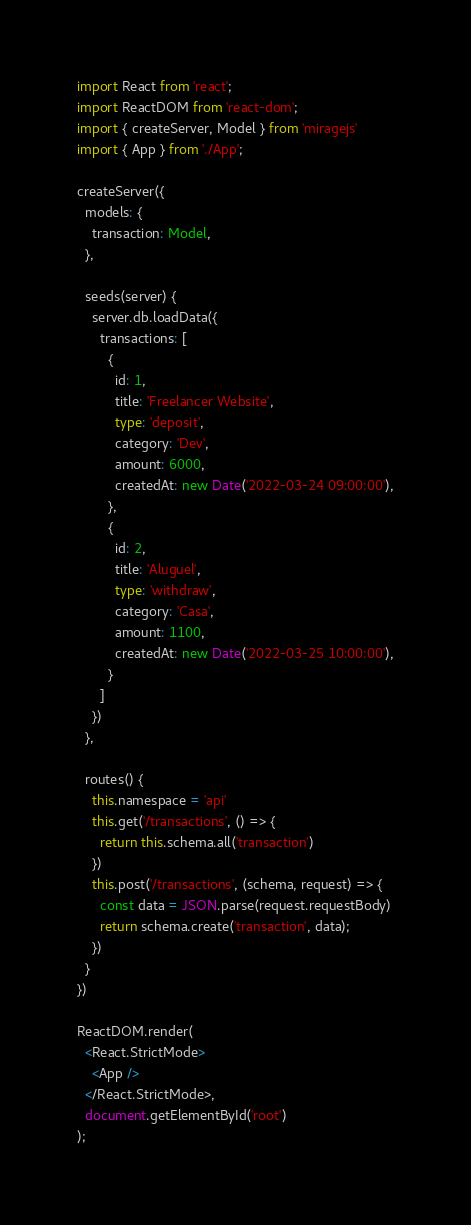<code> <loc_0><loc_0><loc_500><loc_500><_TypeScript_>import React from 'react';
import ReactDOM from 'react-dom';
import { createServer, Model } from 'miragejs'
import { App } from './App';

createServer({
  models: {
    transaction: Model,
  },

  seeds(server) {
    server.db.loadData({
      transactions: [
        {
          id: 1,
          title: 'Freelancer Website',
          type: 'deposit',
          category: 'Dev',
          amount: 6000,
          createdAt: new Date('2022-03-24 09:00:00'),
        },
        {
          id: 2,
          title: 'Aluguel',
          type: 'withdraw',
          category: 'Casa',
          amount: 1100,
          createdAt: new Date('2022-03-25 10:00:00'),
        }
      ]
    })
  },

  routes() {
    this.namespace = 'api'
    this.get('/transactions', () => {
      return this.schema.all('transaction')
    })
    this.post('/transactions', (schema, request) => {
      const data = JSON.parse(request.requestBody)
      return schema.create('transaction', data);
    })
  }
})

ReactDOM.render(
  <React.StrictMode>
    <App />
  </React.StrictMode>,
  document.getElementById('root')
);
</code> 